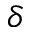<formula> <loc_0><loc_0><loc_500><loc_500>\delta</formula> 